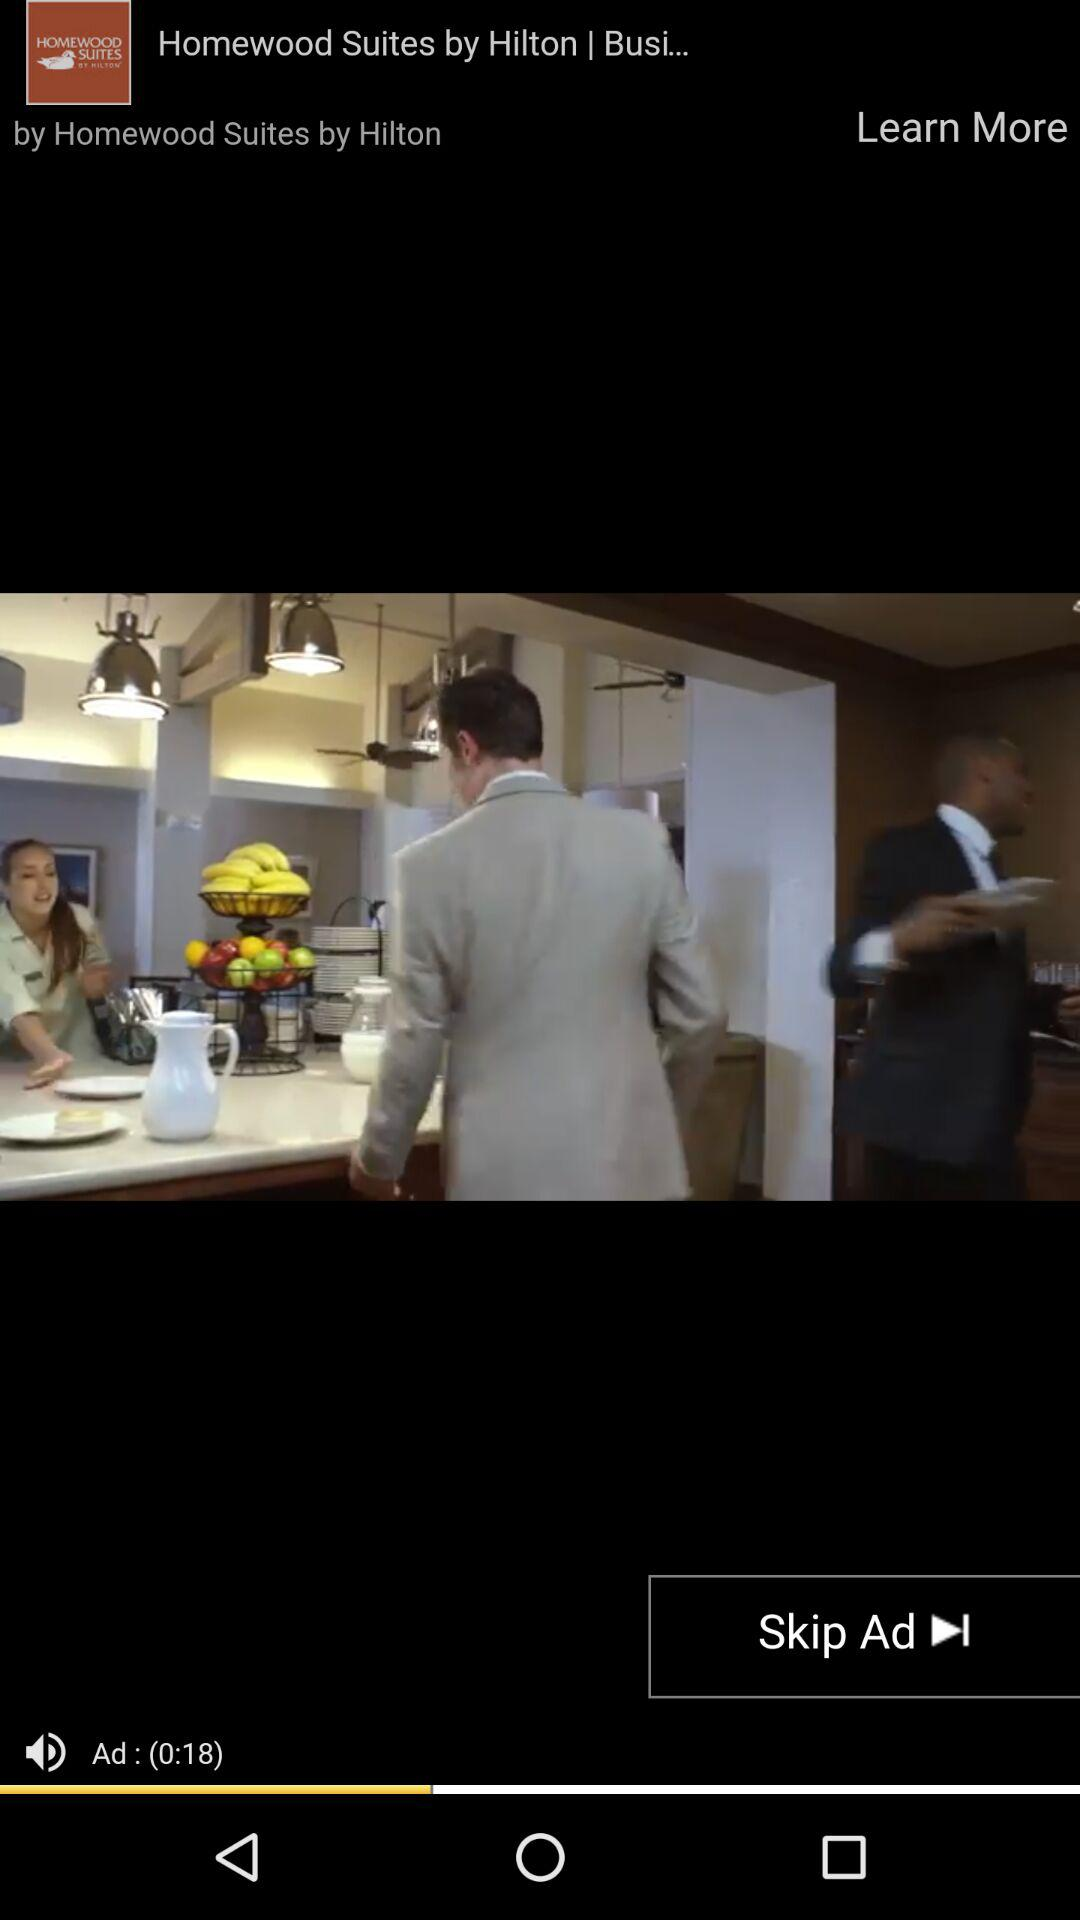How many seconds long is the ad?
Answer the question using a single word or phrase. 18 